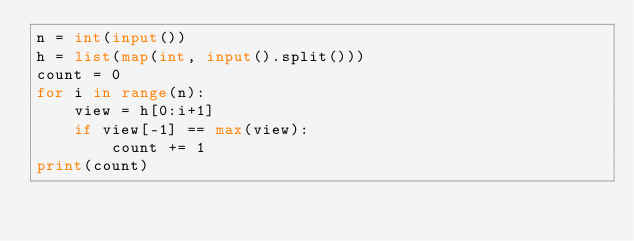<code> <loc_0><loc_0><loc_500><loc_500><_Python_>n = int(input())
h = list(map(int, input().split()))
count = 0
for i in range(n):
    view = h[0:i+1]
    if view[-1] == max(view):
        count += 1
print(count)</code> 